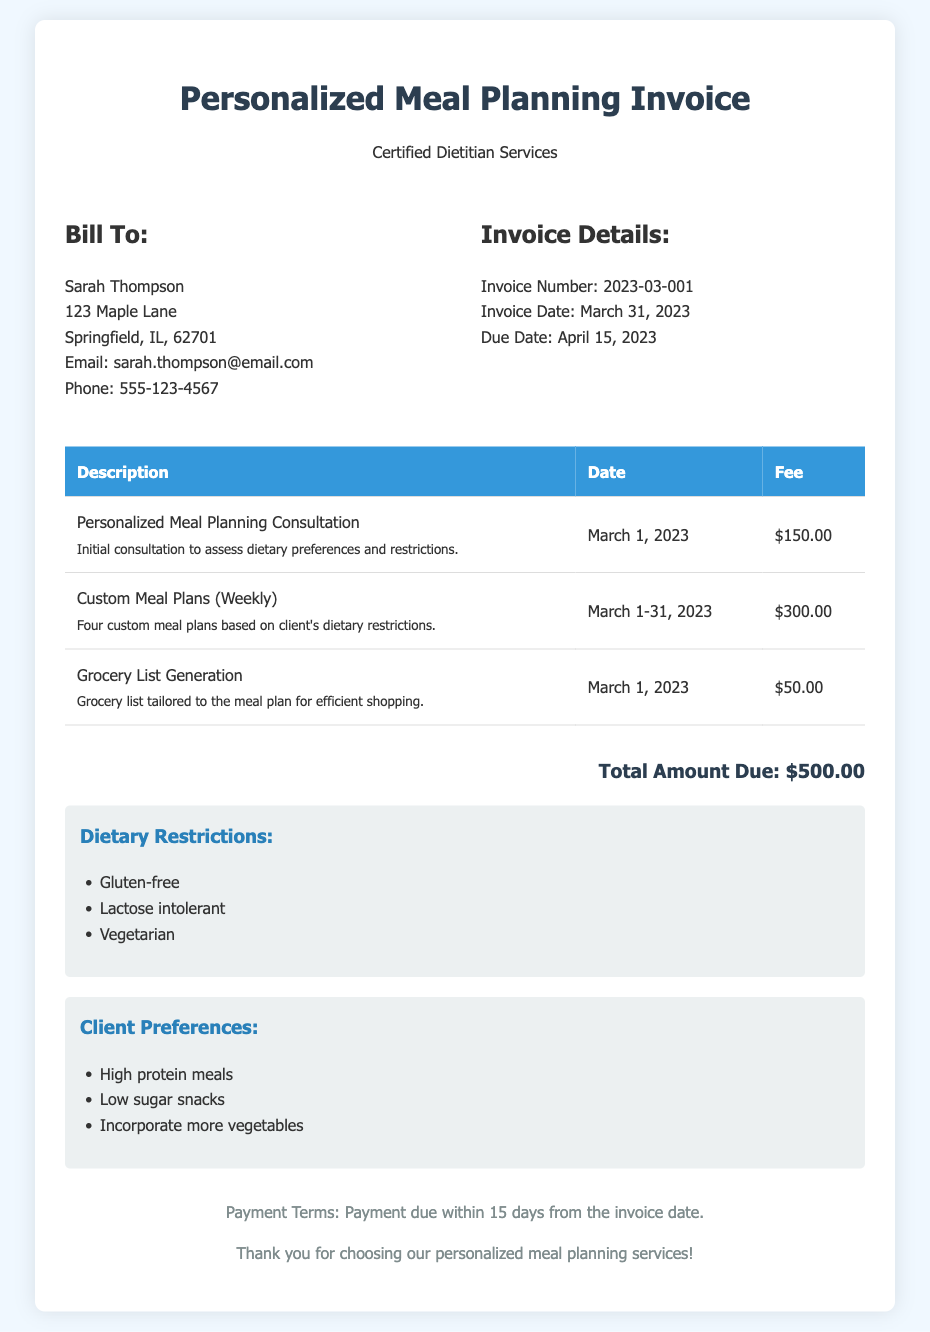What is the name of the client? The name of the client is mentioned at the beginning of the invoice in the billing address section.
Answer: Sarah Thompson What is the total amount due? The total amount due is listed at the bottom of the invoice, summarizing all fees.
Answer: $500.00 When was the invoice issued? The invoice date is specifically stated in the invoice details section.
Answer: March 31, 2023 What services were provided during March 2023? The services are listed in the table with descriptions, dates, and fees.
Answer: Personalized Meal Planning Consultation, Custom Meal Plans (Weekly), Grocery List Generation Which dietary restrictions are listed for the client? The dietary restrictions are noted in a dedicated section below the fee summary.
Answer: Gluten-free, Lactose intolerant, Vegetarian What preferences does the client have for their meals? The client preferences are highlighted in their own section and include specific requests.
Answer: High protein meals, Low sugar snacks, Incorporate more vegetables What is the due date for the invoice payment? The due date is mentioned in the invoice details, indicating when payment is required.
Answer: April 15, 2023 How many custom meal plans were provided in March? The invoice specifies that four custom meal plans were created for the client during March.
Answer: Four What was the date of the initial consultation? The date of the personalized meal planning consultation is recorded in the service description.
Answer: March 1, 2023 